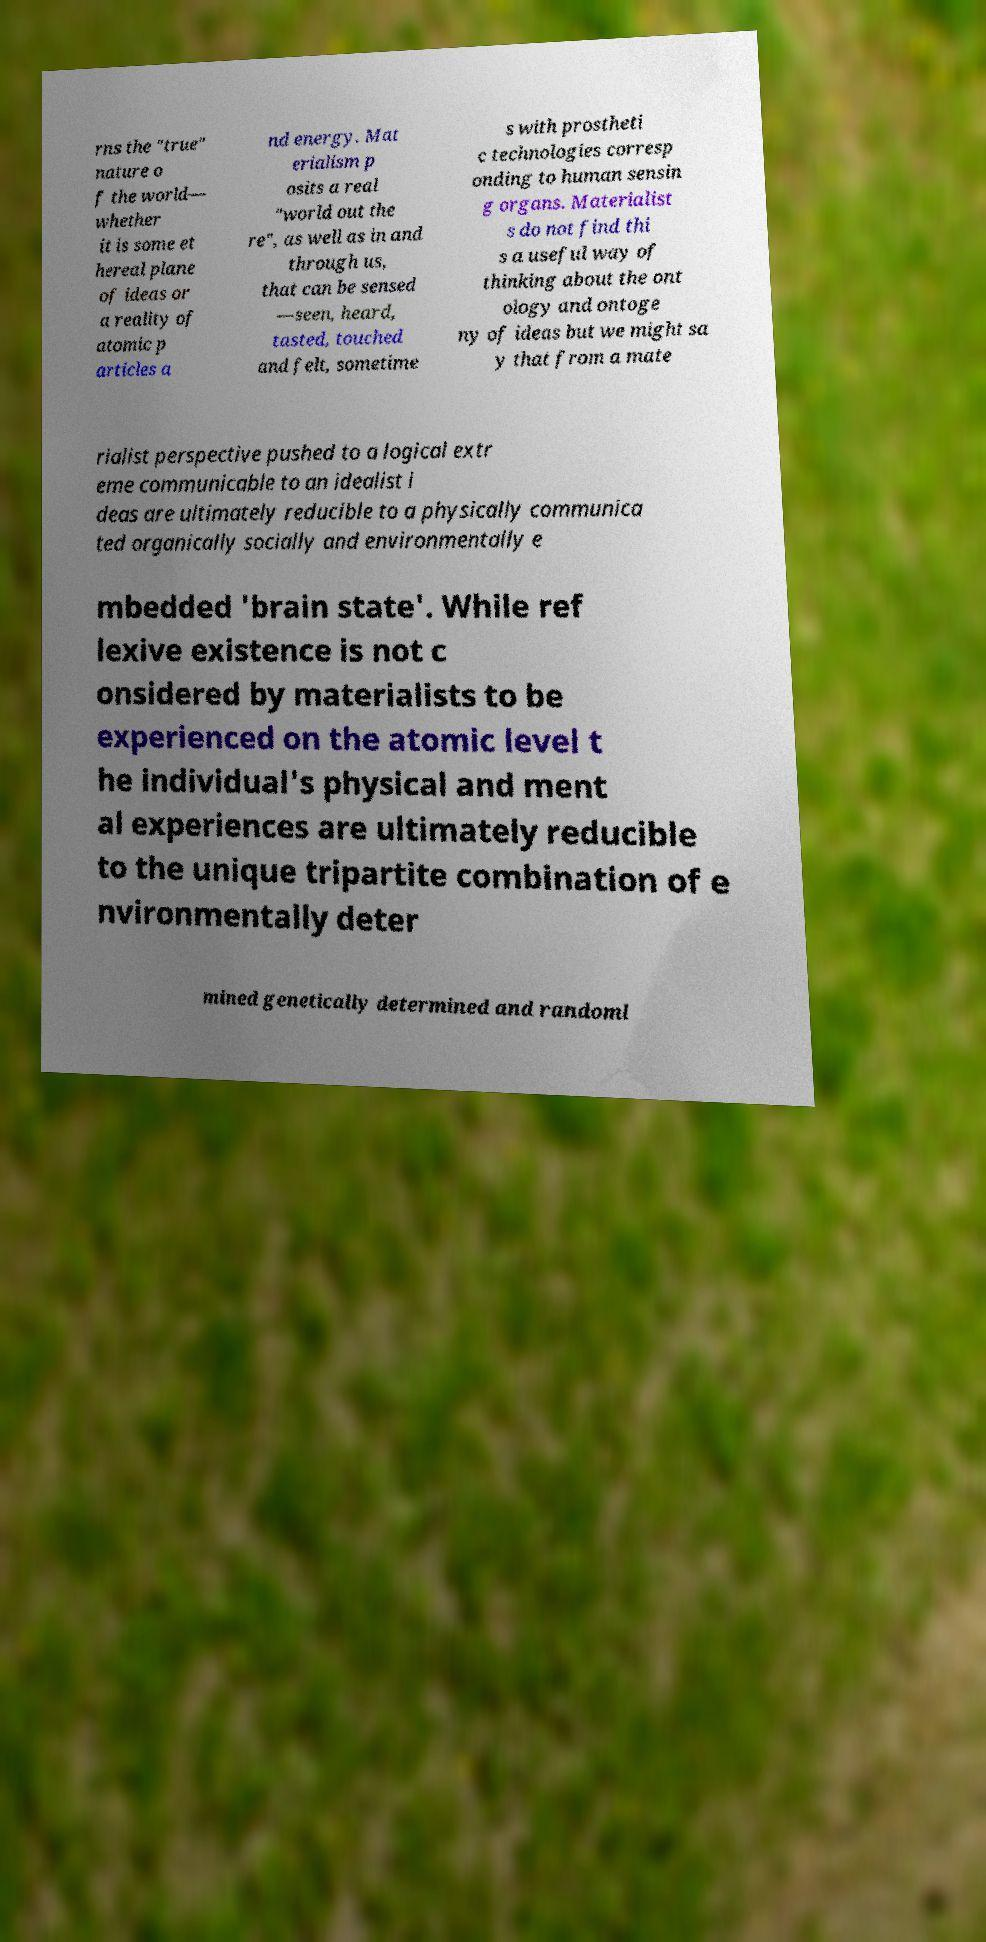Please identify and transcribe the text found in this image. rns the "true" nature o f the world— whether it is some et hereal plane of ideas or a reality of atomic p articles a nd energy. Mat erialism p osits a real "world out the re", as well as in and through us, that can be sensed —seen, heard, tasted, touched and felt, sometime s with prostheti c technologies corresp onding to human sensin g organs. Materialist s do not find thi s a useful way of thinking about the ont ology and ontoge ny of ideas but we might sa y that from a mate rialist perspective pushed to a logical extr eme communicable to an idealist i deas are ultimately reducible to a physically communica ted organically socially and environmentally e mbedded 'brain state'. While ref lexive existence is not c onsidered by materialists to be experienced on the atomic level t he individual's physical and ment al experiences are ultimately reducible to the unique tripartite combination of e nvironmentally deter mined genetically determined and randoml 